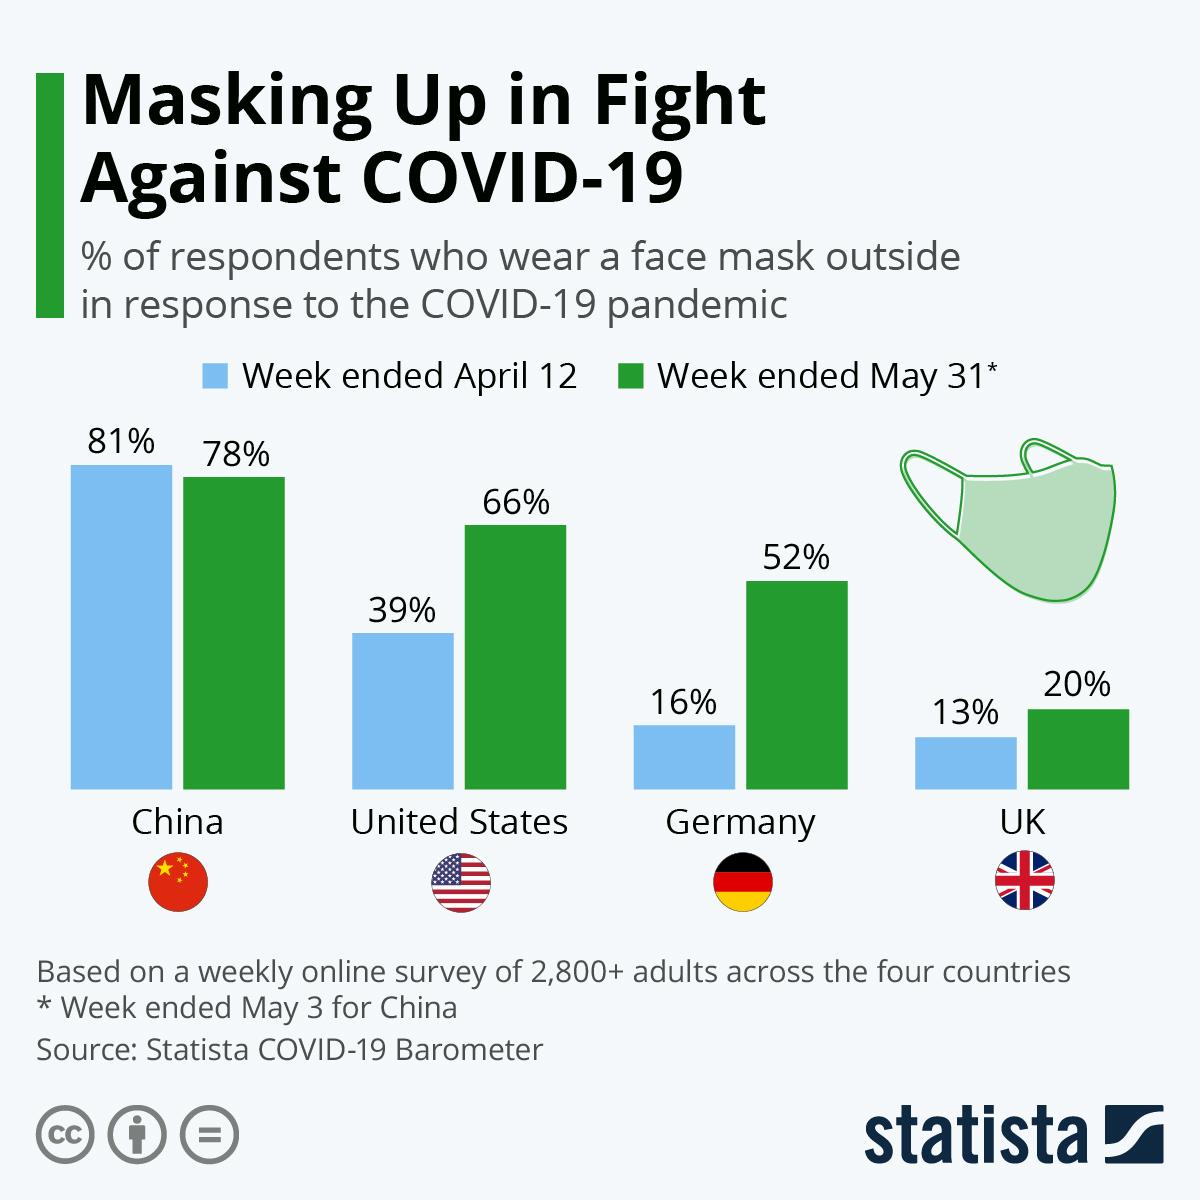List a handful of essential elements in this visual. As of the week ended on May 31st, the country with the largest drop in respondents wearing masks was China. The percentage of people wearing masks in Germany increased by 36% from April to May. The German flag consists of three colors: black, red, and yellow, in a horizontal stripe pattern. The infographic features one mask that is prominently displayed. The percentage of respondents wearing face masks increased by 27% from April to May in the United States. 